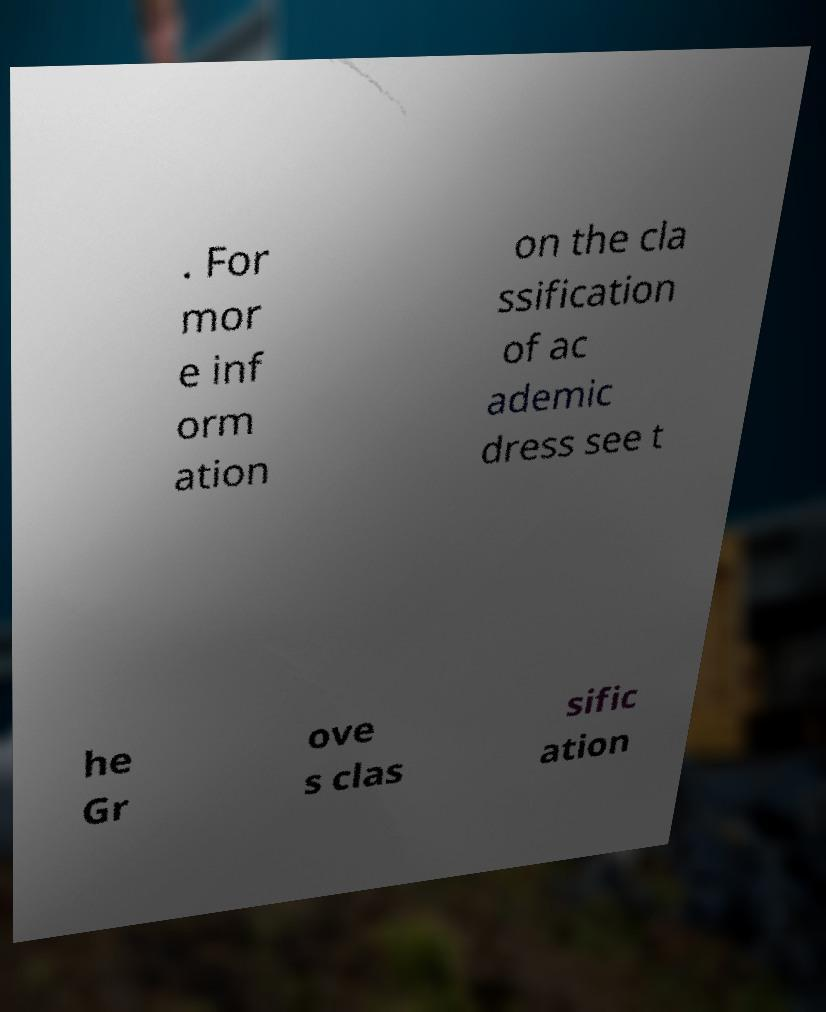Please read and relay the text visible in this image. What does it say? . For mor e inf orm ation on the cla ssification of ac ademic dress see t he Gr ove s clas sific ation 